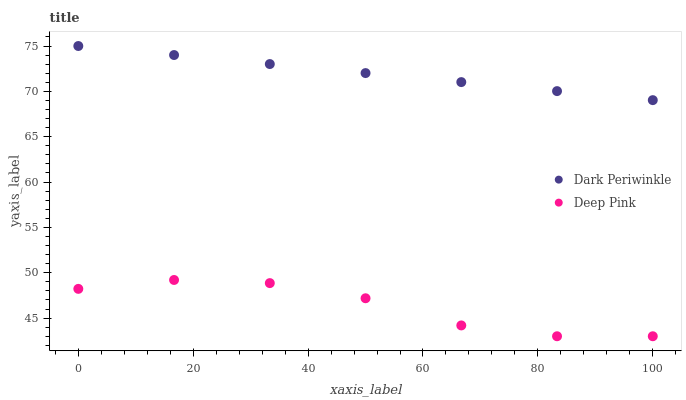Does Deep Pink have the minimum area under the curve?
Answer yes or no. Yes. Does Dark Periwinkle have the maximum area under the curve?
Answer yes or no. Yes. Does Dark Periwinkle have the minimum area under the curve?
Answer yes or no. No. Is Dark Periwinkle the smoothest?
Answer yes or no. Yes. Is Deep Pink the roughest?
Answer yes or no. Yes. Is Dark Periwinkle the roughest?
Answer yes or no. No. Does Deep Pink have the lowest value?
Answer yes or no. Yes. Does Dark Periwinkle have the lowest value?
Answer yes or no. No. Does Dark Periwinkle have the highest value?
Answer yes or no. Yes. Is Deep Pink less than Dark Periwinkle?
Answer yes or no. Yes. Is Dark Periwinkle greater than Deep Pink?
Answer yes or no. Yes. Does Deep Pink intersect Dark Periwinkle?
Answer yes or no. No. 